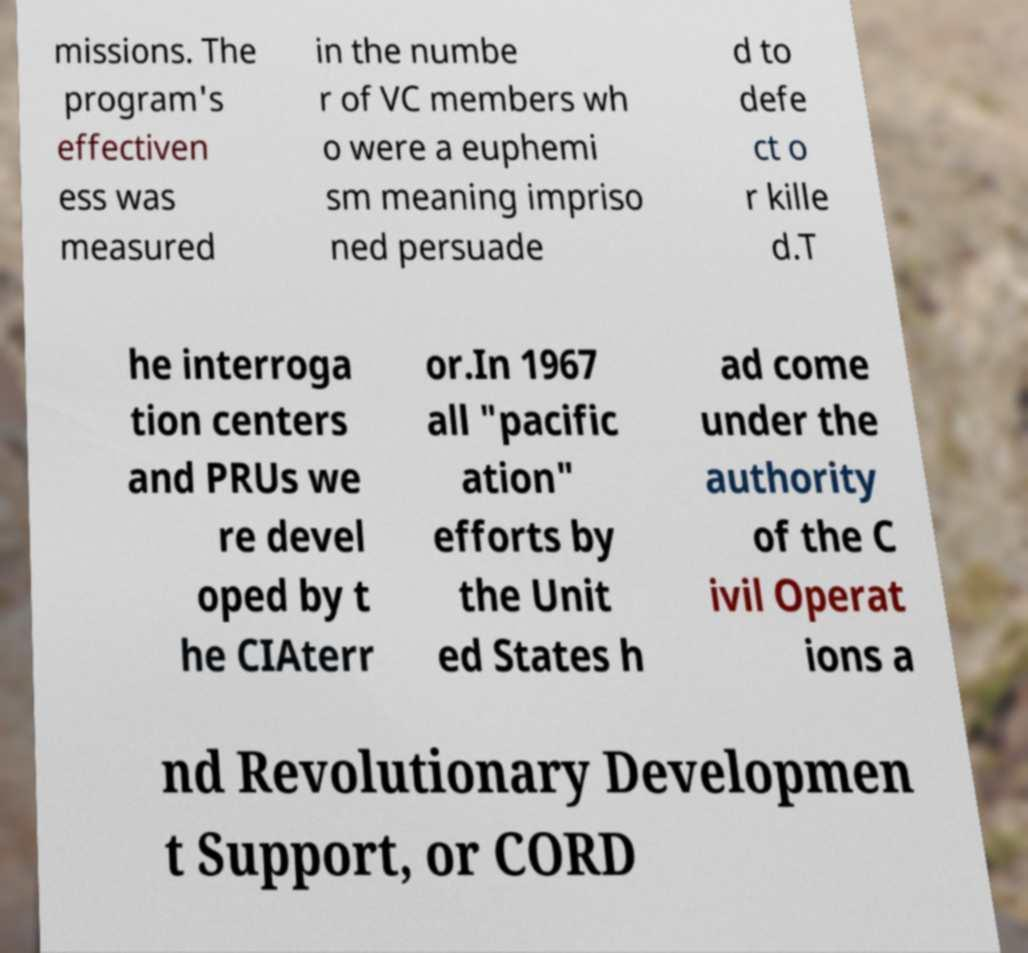Please read and relay the text visible in this image. What does it say? missions. The program's effectiven ess was measured in the numbe r of VC members wh o were a euphemi sm meaning impriso ned persuade d to defe ct o r kille d.T he interroga tion centers and PRUs we re devel oped by t he CIAterr or.In 1967 all "pacific ation" efforts by the Unit ed States h ad come under the authority of the C ivil Operat ions a nd Revolutionary Developmen t Support, or CORD 